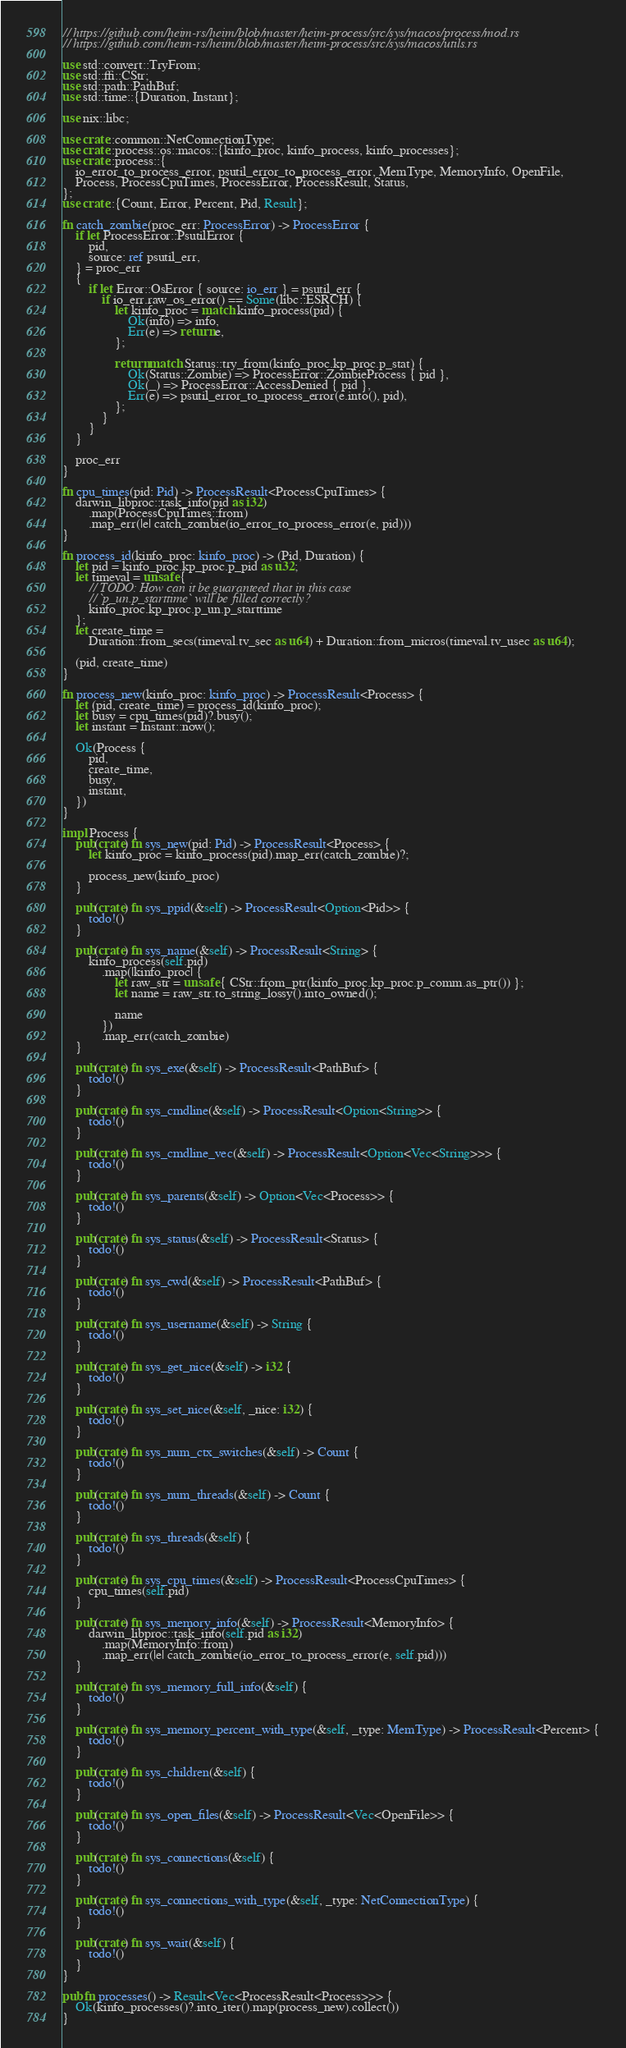<code> <loc_0><loc_0><loc_500><loc_500><_Rust_>// https://github.com/heim-rs/heim/blob/master/heim-process/src/sys/macos/process/mod.rs
// https://github.com/heim-rs/heim/blob/master/heim-process/src/sys/macos/utils.rs

use std::convert::TryFrom;
use std::ffi::CStr;
use std::path::PathBuf;
use std::time::{Duration, Instant};

use nix::libc;

use crate::common::NetConnectionType;
use crate::process::os::macos::{kinfo_proc, kinfo_process, kinfo_processes};
use crate::process::{
	io_error_to_process_error, psutil_error_to_process_error, MemType, MemoryInfo, OpenFile,
	Process, ProcessCpuTimes, ProcessError, ProcessResult, Status,
};
use crate::{Count, Error, Percent, Pid, Result};

fn catch_zombie(proc_err: ProcessError) -> ProcessError {
	if let ProcessError::PsutilError {
		pid,
		source: ref psutil_err,
	} = proc_err
	{
		if let Error::OsError { source: io_err } = psutil_err {
			if io_err.raw_os_error() == Some(libc::ESRCH) {
				let kinfo_proc = match kinfo_process(pid) {
					Ok(info) => info,
					Err(e) => return e,
				};

				return match Status::try_from(kinfo_proc.kp_proc.p_stat) {
					Ok(Status::Zombie) => ProcessError::ZombieProcess { pid },
					Ok(_) => ProcessError::AccessDenied { pid },
					Err(e) => psutil_error_to_process_error(e.into(), pid),
				};
			}
		}
	}

	proc_err
}

fn cpu_times(pid: Pid) -> ProcessResult<ProcessCpuTimes> {
	darwin_libproc::task_info(pid as i32)
		.map(ProcessCpuTimes::from)
		.map_err(|e| catch_zombie(io_error_to_process_error(e, pid)))
}

fn process_id(kinfo_proc: kinfo_proc) -> (Pid, Duration) {
	let pid = kinfo_proc.kp_proc.p_pid as u32;
	let timeval = unsafe {
		// TODO: How can it be guaranteed that in this case
		// `p_un.p_starttime` will be filled correctly?
		kinfo_proc.kp_proc.p_un.p_starttime
	};
	let create_time =
		Duration::from_secs(timeval.tv_sec as u64) + Duration::from_micros(timeval.tv_usec as u64);

	(pid, create_time)
}

fn process_new(kinfo_proc: kinfo_proc) -> ProcessResult<Process> {
	let (pid, create_time) = process_id(kinfo_proc);
	let busy = cpu_times(pid)?.busy();
	let instant = Instant::now();

	Ok(Process {
		pid,
		create_time,
		busy,
		instant,
	})
}

impl Process {
	pub(crate) fn sys_new(pid: Pid) -> ProcessResult<Process> {
		let kinfo_proc = kinfo_process(pid).map_err(catch_zombie)?;

		process_new(kinfo_proc)
	}

	pub(crate) fn sys_ppid(&self) -> ProcessResult<Option<Pid>> {
		todo!()
	}

	pub(crate) fn sys_name(&self) -> ProcessResult<String> {
		kinfo_process(self.pid)
			.map(|kinfo_proc| {
				let raw_str = unsafe { CStr::from_ptr(kinfo_proc.kp_proc.p_comm.as_ptr()) };
				let name = raw_str.to_string_lossy().into_owned();

				name
			})
			.map_err(catch_zombie)
	}

	pub(crate) fn sys_exe(&self) -> ProcessResult<PathBuf> {
		todo!()
	}

	pub(crate) fn sys_cmdline(&self) -> ProcessResult<Option<String>> {
		todo!()
	}

	pub(crate) fn sys_cmdline_vec(&self) -> ProcessResult<Option<Vec<String>>> {
		todo!()
	}

	pub(crate) fn sys_parents(&self) -> Option<Vec<Process>> {
		todo!()
	}

	pub(crate) fn sys_status(&self) -> ProcessResult<Status> {
		todo!()
	}

	pub(crate) fn sys_cwd(&self) -> ProcessResult<PathBuf> {
		todo!()
	}

	pub(crate) fn sys_username(&self) -> String {
		todo!()
	}

	pub(crate) fn sys_get_nice(&self) -> i32 {
		todo!()
	}

	pub(crate) fn sys_set_nice(&self, _nice: i32) {
		todo!()
	}

	pub(crate) fn sys_num_ctx_switches(&self) -> Count {
		todo!()
	}

	pub(crate) fn sys_num_threads(&self) -> Count {
		todo!()
	}

	pub(crate) fn sys_threads(&self) {
		todo!()
	}

	pub(crate) fn sys_cpu_times(&self) -> ProcessResult<ProcessCpuTimes> {
		cpu_times(self.pid)
	}

	pub(crate) fn sys_memory_info(&self) -> ProcessResult<MemoryInfo> {
		darwin_libproc::task_info(self.pid as i32)
			.map(MemoryInfo::from)
			.map_err(|e| catch_zombie(io_error_to_process_error(e, self.pid)))
	}

	pub(crate) fn sys_memory_full_info(&self) {
		todo!()
	}

	pub(crate) fn sys_memory_percent_with_type(&self, _type: MemType) -> ProcessResult<Percent> {
		todo!()
	}

	pub(crate) fn sys_children(&self) {
		todo!()
	}

	pub(crate) fn sys_open_files(&self) -> ProcessResult<Vec<OpenFile>> {
		todo!()
	}

	pub(crate) fn sys_connections(&self) {
		todo!()
	}

	pub(crate) fn sys_connections_with_type(&self, _type: NetConnectionType) {
		todo!()
	}

	pub(crate) fn sys_wait(&self) {
		todo!()
	}
}

pub fn processes() -> Result<Vec<ProcessResult<Process>>> {
	Ok(kinfo_processes()?.into_iter().map(process_new).collect())
}
</code> 